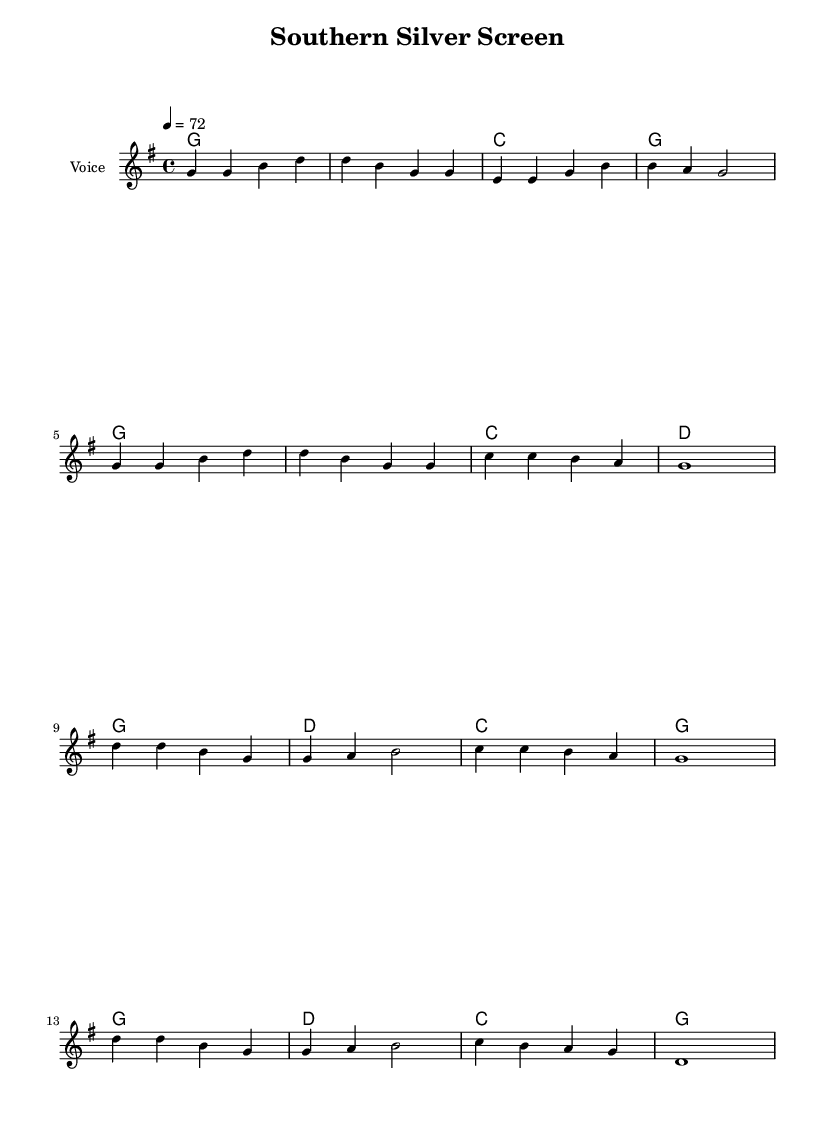What is the key signature of this music? The key signature is indicated at the beginning of the score and shows one sharp (F#), which means it's in G major.
Answer: G major What is the time signature of the piece? The time signature is shown near the beginning of the score, and it indicates that there are four beats per measure.
Answer: 4/4 What is the tempo marking for this piece? The tempo is notated at the start and shows a quarter note equals 72 beats per minute, indicating the pace of the music.
Answer: 72 How many measures are in the verse section? By counting the measures in the melody section labeled as the verse, we see there are eight measures in total.
Answer: Eight What are the harmonies used in the chorus section? The score indicates the chord symbols above the melody, which shows that the chorus utilizes the chords G, D, and C.
Answer: G, D, C What cultural elements are referenced in the lyrics of the song? The lyrics speak of the South, mentioning "Gone with the Wind," which indicates a connection to Southern history and cultural narratives depicted in film.
Answer: Southern history 